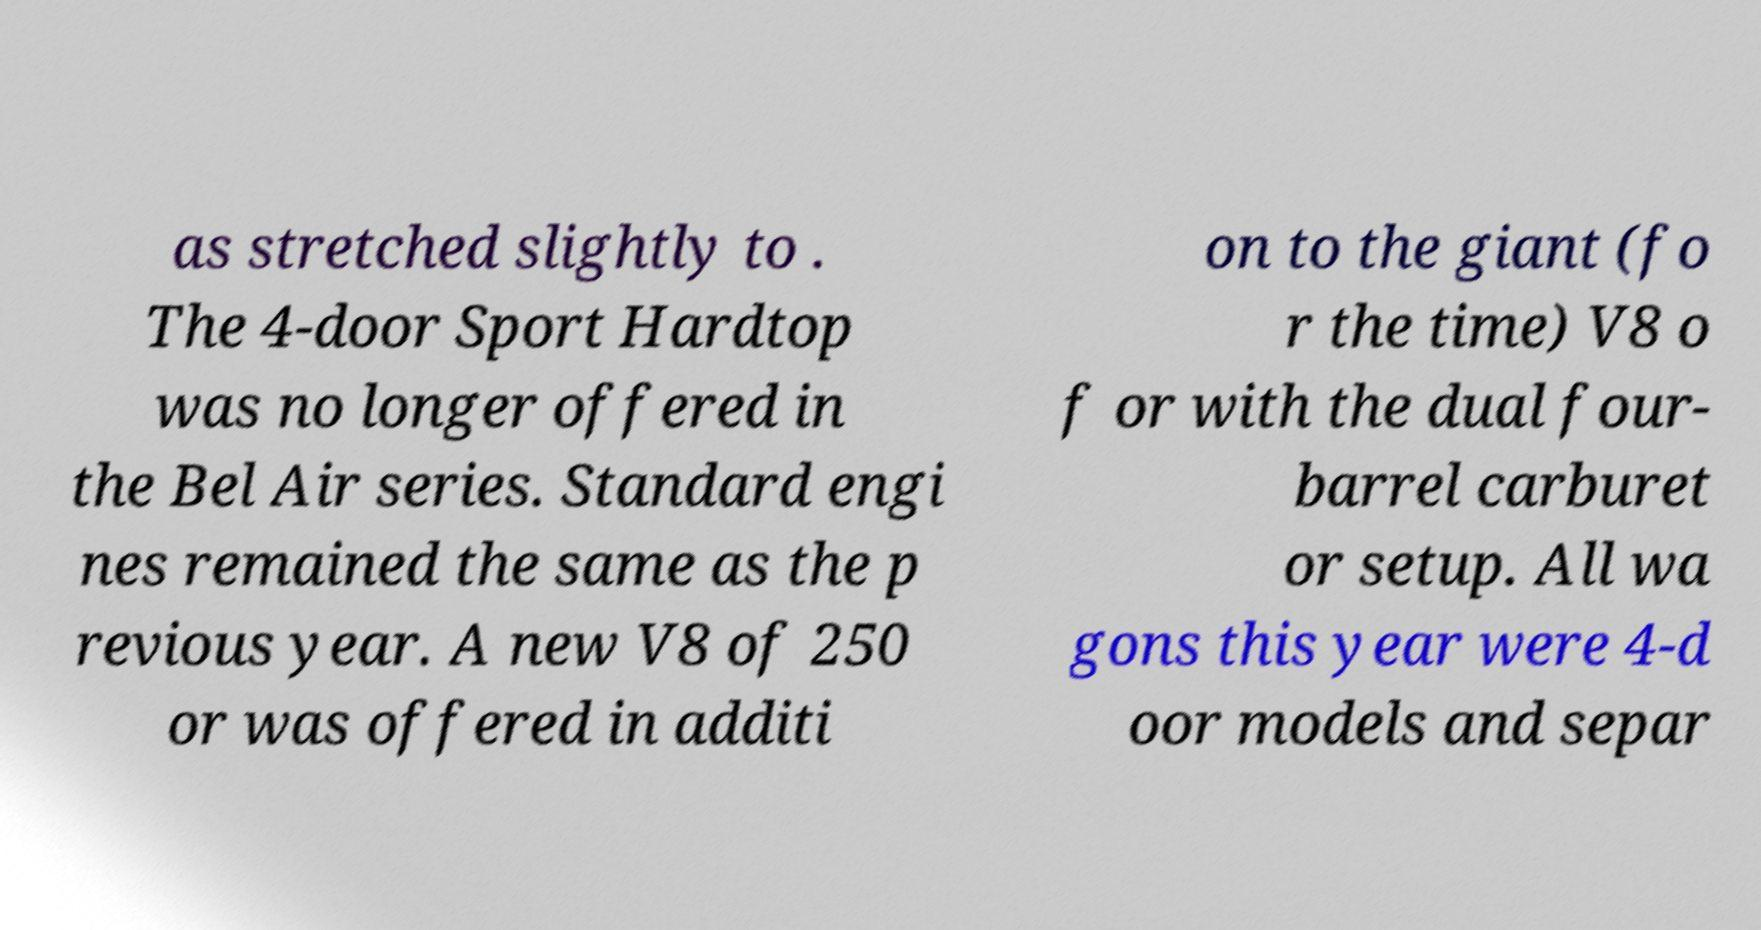Can you accurately transcribe the text from the provided image for me? as stretched slightly to . The 4-door Sport Hardtop was no longer offered in the Bel Air series. Standard engi nes remained the same as the p revious year. A new V8 of 250 or was offered in additi on to the giant (fo r the time) V8 o f or with the dual four- barrel carburet or setup. All wa gons this year were 4-d oor models and separ 